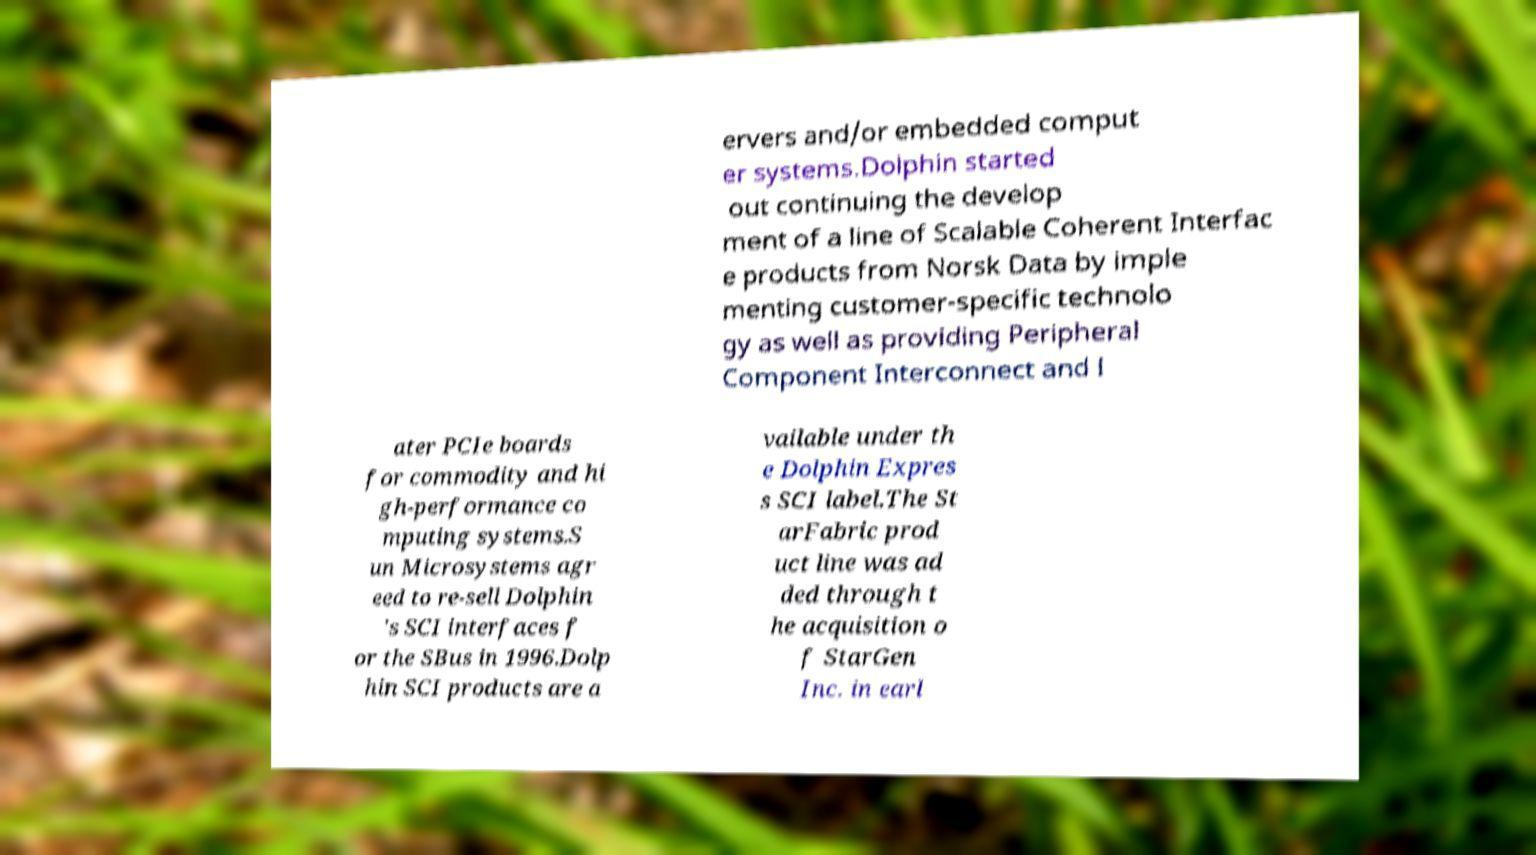Can you read and provide the text displayed in the image?This photo seems to have some interesting text. Can you extract and type it out for me? ervers and/or embedded comput er systems.Dolphin started out continuing the develop ment of a line of Scalable Coherent Interfac e products from Norsk Data by imple menting customer-specific technolo gy as well as providing Peripheral Component Interconnect and l ater PCIe boards for commodity and hi gh-performance co mputing systems.S un Microsystems agr eed to re-sell Dolphin 's SCI interfaces f or the SBus in 1996.Dolp hin SCI products are a vailable under th e Dolphin Expres s SCI label.The St arFabric prod uct line was ad ded through t he acquisition o f StarGen Inc. in earl 